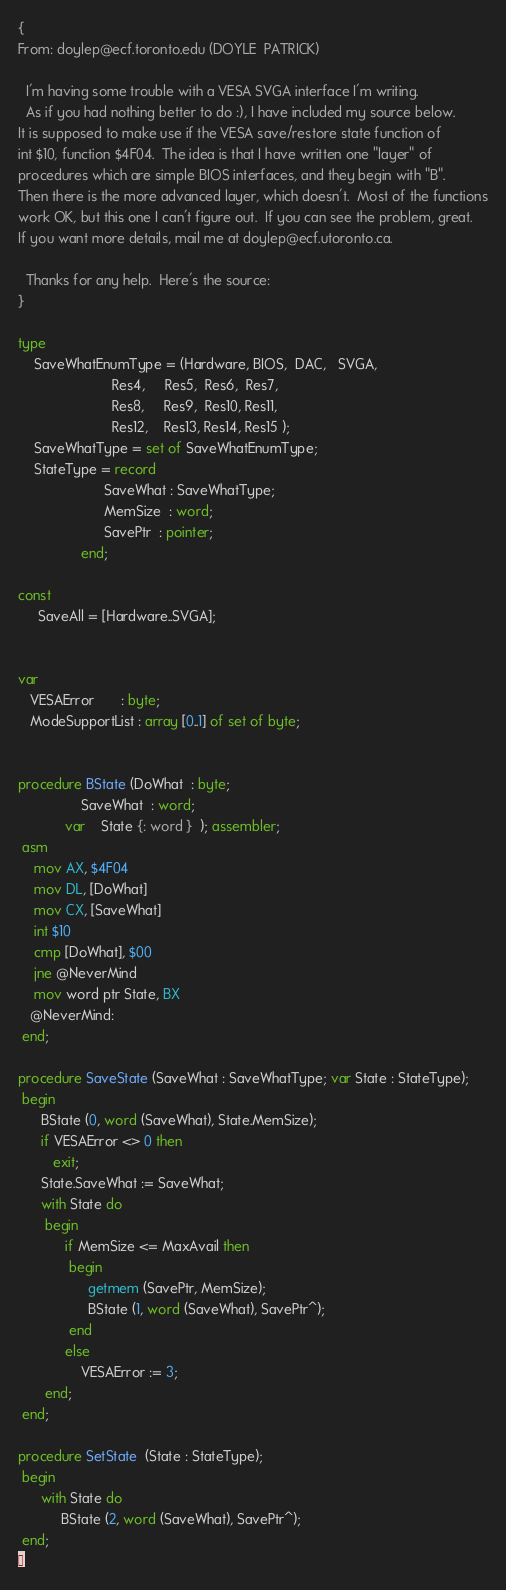Convert code to text. <code><loc_0><loc_0><loc_500><loc_500><_Pascal_>{
From: doylep@ecf.toronto.edu (DOYLE  PATRICK)

  I'm having some trouble with a VESA SVGA interface I'm writing.
  As if you had nothing better to do :), I have included my source below.
It is supposed to make use if the VESA save/restore state function of
int $10, function $4F04.  The idea is that I have written one "layer" of
procedures which are simple BIOS interfaces, and they begin with "B".
Then there is the more advanced layer, which doesn't.  Most of the functions
work OK, but this one I can't figure out.  If you can see the problem, great.
If you want more details, mail me at doylep@ecf.utoronto.ca.

  Thanks for any help.  Here's the source:
}

type
    SaveWhatEnumType = (Hardware, BIOS,  DAC,   SVGA,
                        Res4,     Res5,  Res6,  Res7,
                        Res8,     Res9,  Res10, Res11,
                        Res12,    Res13, Res14, Res15 );
    SaveWhatType = set of SaveWhatEnumType;
    StateType = record
                      SaveWhat : SaveWhatType;
                      MemSize  : word;
                      SavePtr  : pointer;
                end;
 
const
     SaveAll = [Hardware..SVGA];
 

var
   VESAError       : byte;
   ModeSupportList : array [0..1] of set of byte;


procedure BState (DoWhat  : byte;
                SaveWhat  : word;
            var    State {: word }  ); assembler; 
 asm
    mov AX, $4F04
    mov DL, [DoWhat]
    mov CX, [SaveWhat]
    int $10
    cmp [DoWhat], $00
    jne @NeverMind
    mov word ptr State, BX
   @NeverMind:
 end;
 
procedure SaveState (SaveWhat : SaveWhatType; var State : StateType);
 begin
      BState (0, word (SaveWhat), State.MemSize);
      if VESAError <> 0 then
         exit;
      State.SaveWhat := SaveWhat;
      with State do
       begin
            if MemSize <= MaxAvail then
             begin
                  getmem (SavePtr, MemSize);
                  BState (1, word (SaveWhat), SavePtr^);
             end
            else
                VESAError := 3;
       end;
 end;
 
procedure SetState  (State : StateType);
 begin
      with State do
           BState (2, word (SaveWhat), SavePtr^);
 end;
</code> 